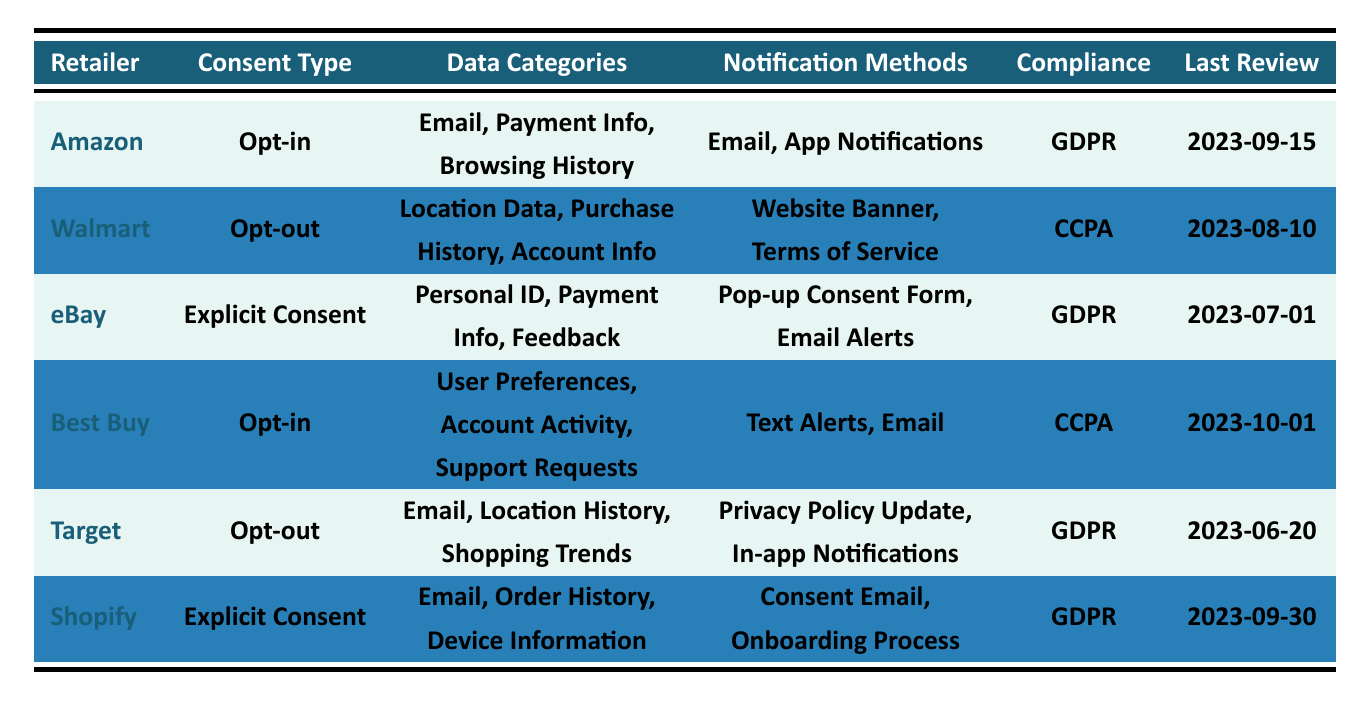What is the consent type used by Amazon? The table shows that Amazon's consent type is listed under the "Consent Type" column directly adjacent to its name. It states "Opt-in."
Answer: Opt-in Which retailer has the most recent last review date? By comparing the "Last Review" dates across all retailers, we see Best Buy has the latest date of "2023-10-01."
Answer: Best Buy How many retailers collect email data? The retailers that collect email data are Amazon, eBay, Target, and Shopify. Counting these gives us a total of 4 retailers.
Answer: 4 Is Walmart compliant with GDPR? The compliance standard for Walmart is listed as "CCPA," which means it is not compliant with GDPR.
Answer: No What is the compliance standard for eBay, and what is the corresponding consent type? By checking the "Compliance" column next to eBay, it shows "GDPR," and the "Consent Type" shows "Explicit Consent."
Answer: GDPR, Explicit Consent Which notification method is used by Best Buy? Looking under the "Notification Methods" column for Best Buy, the methods listed are "Text Alerts, Email."
Answer: Text Alerts, Email Are there any retailers that use "Explicit Consent" as their consent type? The table lists eBay and Shopify under the "Consent Type" column as using "Explicit Consent."
Answer: Yes Which data categories are collected by Shopify? The table details that Shopify collects "Email, Order History, Device Information" in the "Data Categories" column.
Answer: Email, Order History, Device Information Which consent type is more common among the retailers listed, "Opt-in" or "Opt-out"? The table shows two retailers have "Opt-in" (Amazon, Best Buy) and two have "Opt-out" (Walmart, Target). Both types are equally common at four retailers each.
Answer: Equal What are the overall categories of data collected by all retailers indexed in the table? By examining the "Data Categories" column for all retailers and listing them, we find the categories include Email, Payment Information, Browsing History, Location Data, Purchase History, Account Information, Personal Identification, Feedback, User Preferences, Account Activity, Support Requests, and Device Information.
Answer: Email, Payment Information, Browsing History, Location Data, Purchase History, Account Information, Personal Identification, Feedback, User Preferences, Account Activity, Support Requests, Device Information Is there a retailer that uses both GDPR and CCPA compliance standards? Examining the table shows that no single retailer is compliant with both standards; each retailer listed is exclusively compliant with either GDPR or CCPA.
Answer: No 